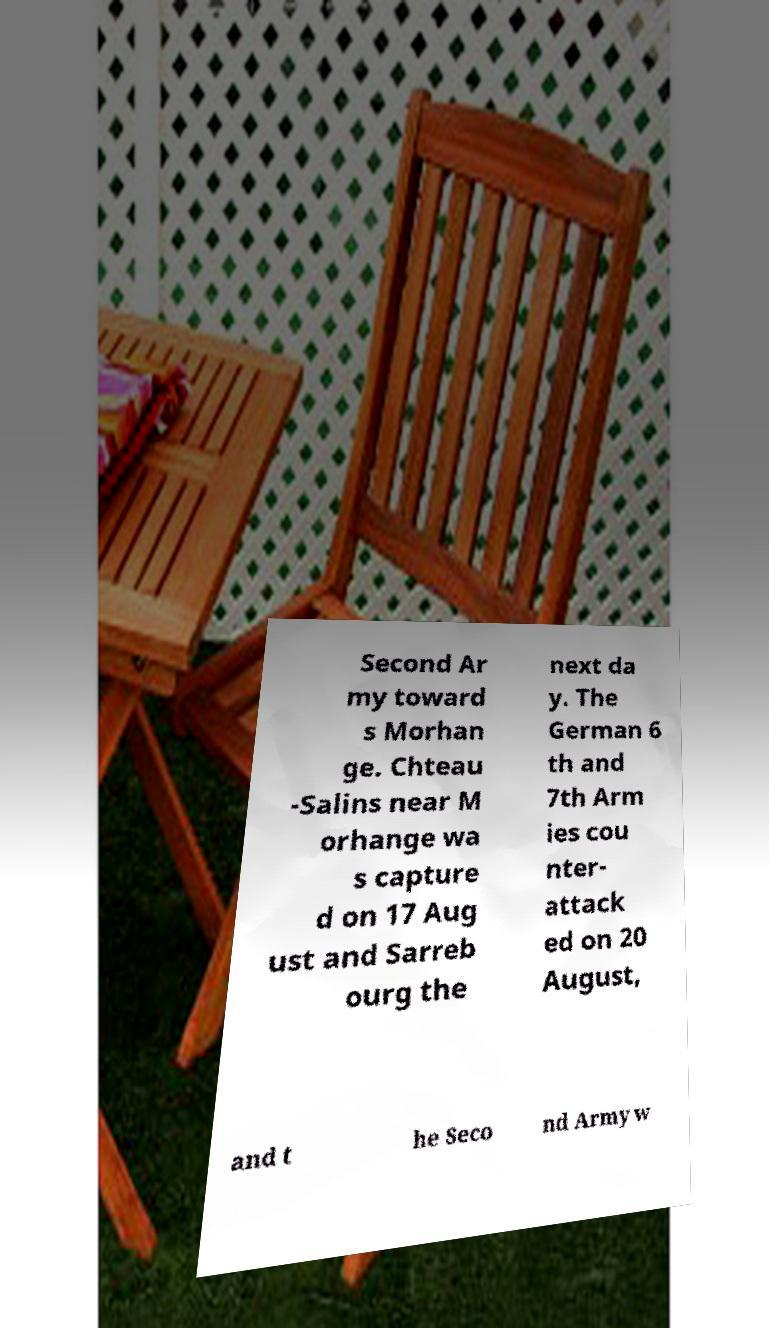For documentation purposes, I need the text within this image transcribed. Could you provide that? Second Ar my toward s Morhan ge. Chteau -Salins near M orhange wa s capture d on 17 Aug ust and Sarreb ourg the next da y. The German 6 th and 7th Arm ies cou nter- attack ed on 20 August, and t he Seco nd Army w 